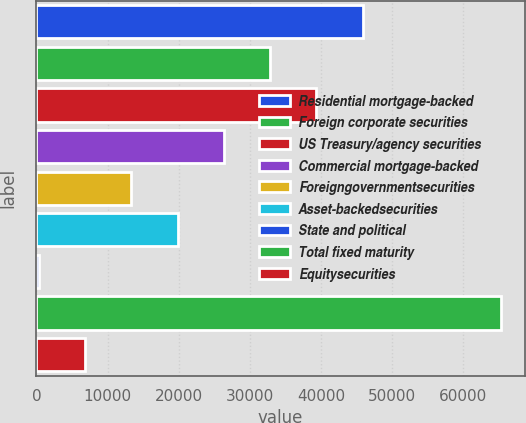Convert chart. <chart><loc_0><loc_0><loc_500><loc_500><bar_chart><fcel>Residential mortgage-backed<fcel>Foreign corporate securities<fcel>US Treasury/agency securities<fcel>Commercial mortgage-backed<fcel>Foreigngovernmentsecurities<fcel>Asset-backedsecurities<fcel>State and political<fcel>Total fixed maturity<fcel>Equitysecurities<nl><fcel>45854.3<fcel>32848.5<fcel>39351.4<fcel>26345.6<fcel>13339.8<fcel>19842.7<fcel>334<fcel>65363<fcel>6836.9<nl></chart> 